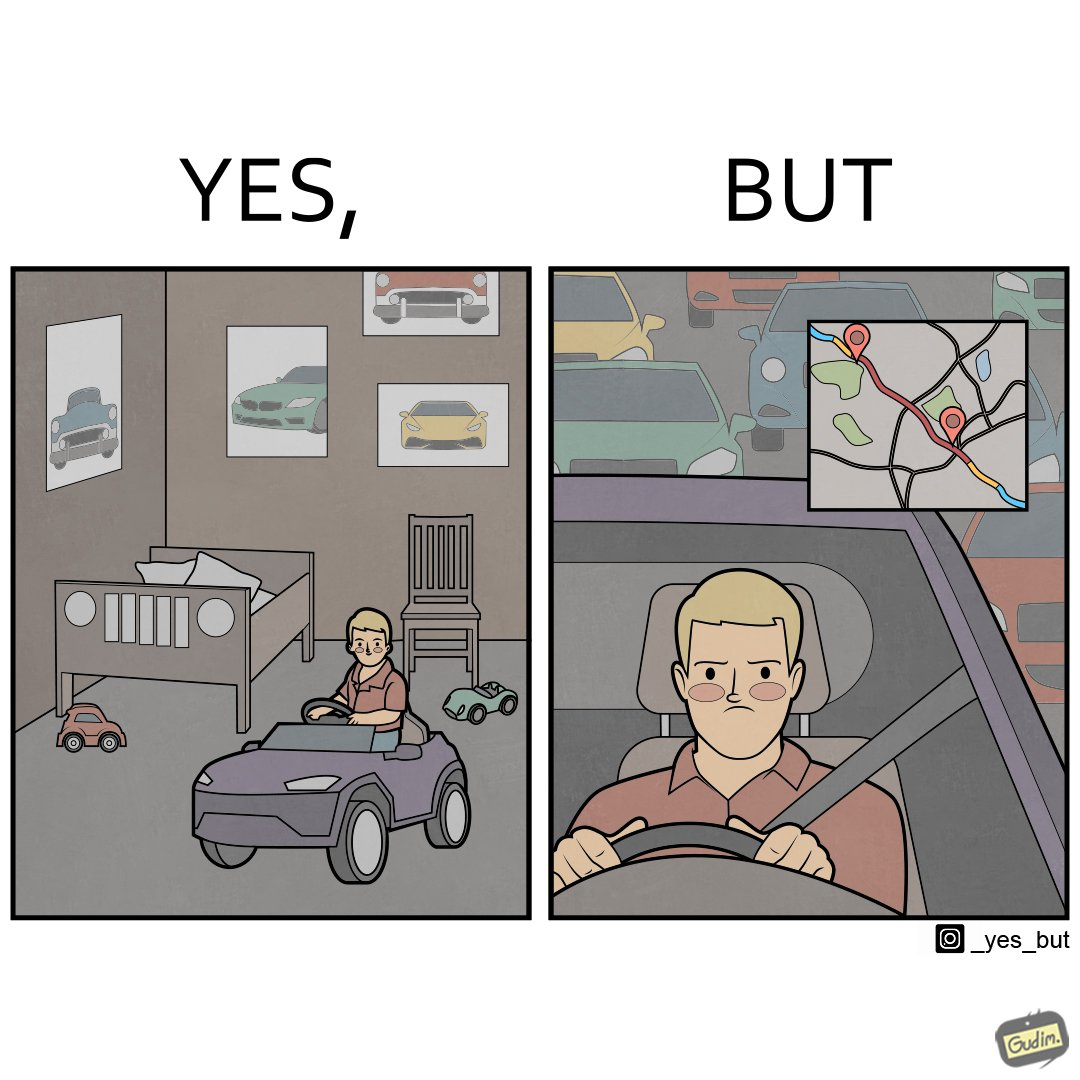Is this image satirical or non-satirical? Yes, this image is satirical. 